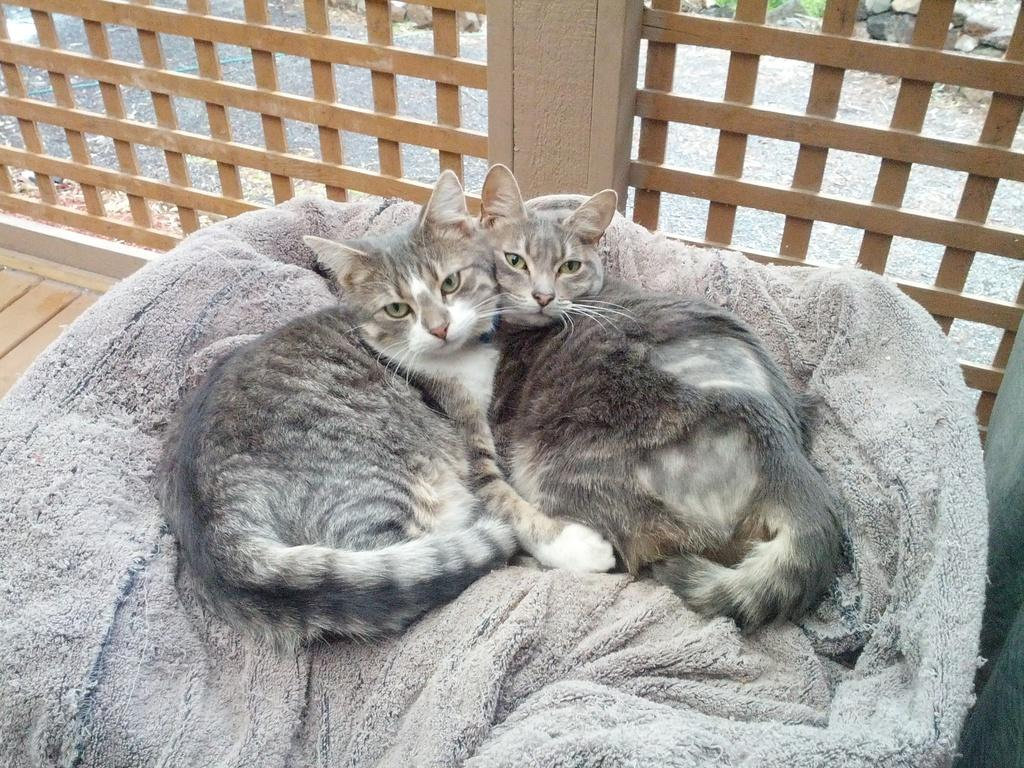What type of animals are on the bed in the image? There are cats on the bed in the image. What material can be seen at the top of the image? There are wooden grills at the top of the image. What type of current is flowing through the lunch in the image? There is no lunch or current present in the image; it features cats on a bed and wooden grills. 